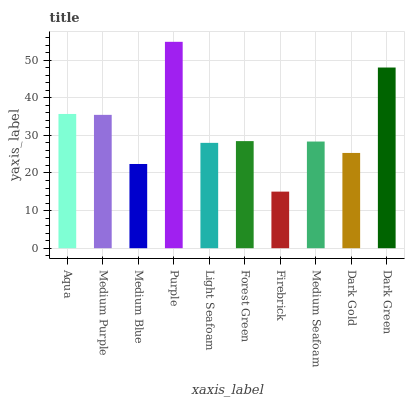Is Firebrick the minimum?
Answer yes or no. Yes. Is Purple the maximum?
Answer yes or no. Yes. Is Medium Purple the minimum?
Answer yes or no. No. Is Medium Purple the maximum?
Answer yes or no. No. Is Aqua greater than Medium Purple?
Answer yes or no. Yes. Is Medium Purple less than Aqua?
Answer yes or no. Yes. Is Medium Purple greater than Aqua?
Answer yes or no. No. Is Aqua less than Medium Purple?
Answer yes or no. No. Is Forest Green the high median?
Answer yes or no. Yes. Is Medium Seafoam the low median?
Answer yes or no. Yes. Is Light Seafoam the high median?
Answer yes or no. No. Is Dark Green the low median?
Answer yes or no. No. 